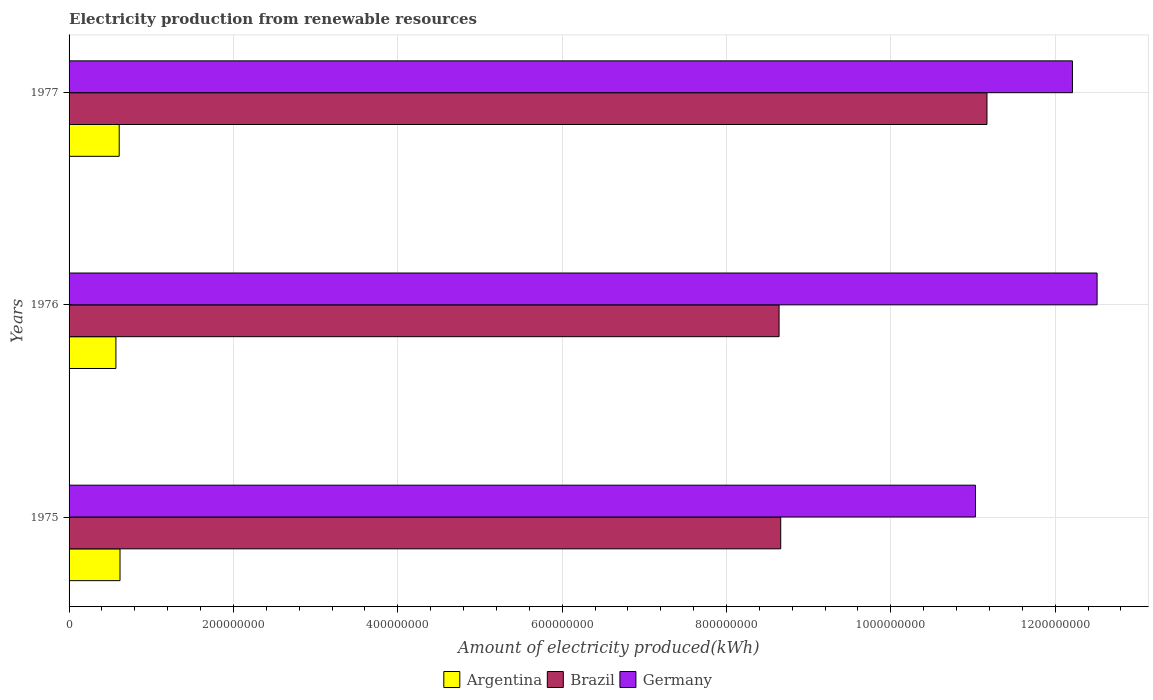How many different coloured bars are there?
Your answer should be compact. 3. Are the number of bars per tick equal to the number of legend labels?
Your response must be concise. Yes. How many bars are there on the 1st tick from the top?
Your response must be concise. 3. What is the label of the 2nd group of bars from the top?
Make the answer very short. 1976. In how many cases, is the number of bars for a given year not equal to the number of legend labels?
Give a very brief answer. 0. What is the amount of electricity produced in Argentina in 1975?
Ensure brevity in your answer.  6.20e+07. Across all years, what is the maximum amount of electricity produced in Brazil?
Offer a terse response. 1.12e+09. Across all years, what is the minimum amount of electricity produced in Brazil?
Provide a short and direct response. 8.64e+08. In which year was the amount of electricity produced in Argentina maximum?
Offer a very short reply. 1975. In which year was the amount of electricity produced in Argentina minimum?
Make the answer very short. 1976. What is the total amount of electricity produced in Brazil in the graph?
Your response must be concise. 2.85e+09. What is the difference between the amount of electricity produced in Germany in 1976 and that in 1977?
Your answer should be very brief. 3.00e+07. What is the difference between the amount of electricity produced in Brazil in 1975 and the amount of electricity produced in Argentina in 1976?
Provide a short and direct response. 8.09e+08. What is the average amount of electricity produced in Germany per year?
Make the answer very short. 1.19e+09. In the year 1977, what is the difference between the amount of electricity produced in Germany and amount of electricity produced in Argentina?
Your answer should be compact. 1.16e+09. What is the ratio of the amount of electricity produced in Argentina in 1975 to that in 1976?
Your response must be concise. 1.09. What is the difference between the highest and the second highest amount of electricity produced in Brazil?
Provide a short and direct response. 2.51e+08. In how many years, is the amount of electricity produced in Brazil greater than the average amount of electricity produced in Brazil taken over all years?
Your answer should be very brief. 1. Is the sum of the amount of electricity produced in Brazil in 1975 and 1976 greater than the maximum amount of electricity produced in Argentina across all years?
Your answer should be compact. Yes. Is it the case that in every year, the sum of the amount of electricity produced in Argentina and amount of electricity produced in Brazil is greater than the amount of electricity produced in Germany?
Your response must be concise. No. How many bars are there?
Provide a succinct answer. 9. What is the difference between two consecutive major ticks on the X-axis?
Offer a terse response. 2.00e+08. Does the graph contain any zero values?
Offer a terse response. No. Does the graph contain grids?
Provide a short and direct response. Yes. How are the legend labels stacked?
Your answer should be very brief. Horizontal. What is the title of the graph?
Your answer should be very brief. Electricity production from renewable resources. Does "Timor-Leste" appear as one of the legend labels in the graph?
Keep it short and to the point. No. What is the label or title of the X-axis?
Keep it short and to the point. Amount of electricity produced(kWh). What is the label or title of the Y-axis?
Your answer should be compact. Years. What is the Amount of electricity produced(kWh) in Argentina in 1975?
Offer a very short reply. 6.20e+07. What is the Amount of electricity produced(kWh) of Brazil in 1975?
Offer a very short reply. 8.66e+08. What is the Amount of electricity produced(kWh) of Germany in 1975?
Your response must be concise. 1.10e+09. What is the Amount of electricity produced(kWh) of Argentina in 1976?
Make the answer very short. 5.70e+07. What is the Amount of electricity produced(kWh) in Brazil in 1976?
Ensure brevity in your answer.  8.64e+08. What is the Amount of electricity produced(kWh) in Germany in 1976?
Give a very brief answer. 1.25e+09. What is the Amount of electricity produced(kWh) in Argentina in 1977?
Provide a succinct answer. 6.10e+07. What is the Amount of electricity produced(kWh) in Brazil in 1977?
Keep it short and to the point. 1.12e+09. What is the Amount of electricity produced(kWh) of Germany in 1977?
Offer a very short reply. 1.22e+09. Across all years, what is the maximum Amount of electricity produced(kWh) in Argentina?
Your response must be concise. 6.20e+07. Across all years, what is the maximum Amount of electricity produced(kWh) in Brazil?
Make the answer very short. 1.12e+09. Across all years, what is the maximum Amount of electricity produced(kWh) of Germany?
Ensure brevity in your answer.  1.25e+09. Across all years, what is the minimum Amount of electricity produced(kWh) in Argentina?
Offer a very short reply. 5.70e+07. Across all years, what is the minimum Amount of electricity produced(kWh) in Brazil?
Ensure brevity in your answer.  8.64e+08. Across all years, what is the minimum Amount of electricity produced(kWh) in Germany?
Make the answer very short. 1.10e+09. What is the total Amount of electricity produced(kWh) in Argentina in the graph?
Your answer should be very brief. 1.80e+08. What is the total Amount of electricity produced(kWh) in Brazil in the graph?
Your answer should be compact. 2.85e+09. What is the total Amount of electricity produced(kWh) of Germany in the graph?
Offer a terse response. 3.58e+09. What is the difference between the Amount of electricity produced(kWh) of Argentina in 1975 and that in 1976?
Provide a succinct answer. 5.00e+06. What is the difference between the Amount of electricity produced(kWh) of Brazil in 1975 and that in 1976?
Keep it short and to the point. 2.00e+06. What is the difference between the Amount of electricity produced(kWh) in Germany in 1975 and that in 1976?
Your response must be concise. -1.48e+08. What is the difference between the Amount of electricity produced(kWh) in Brazil in 1975 and that in 1977?
Keep it short and to the point. -2.51e+08. What is the difference between the Amount of electricity produced(kWh) in Germany in 1975 and that in 1977?
Ensure brevity in your answer.  -1.18e+08. What is the difference between the Amount of electricity produced(kWh) of Argentina in 1976 and that in 1977?
Keep it short and to the point. -4.00e+06. What is the difference between the Amount of electricity produced(kWh) of Brazil in 1976 and that in 1977?
Give a very brief answer. -2.53e+08. What is the difference between the Amount of electricity produced(kWh) in Germany in 1976 and that in 1977?
Provide a short and direct response. 3.00e+07. What is the difference between the Amount of electricity produced(kWh) in Argentina in 1975 and the Amount of electricity produced(kWh) in Brazil in 1976?
Your answer should be very brief. -8.02e+08. What is the difference between the Amount of electricity produced(kWh) of Argentina in 1975 and the Amount of electricity produced(kWh) of Germany in 1976?
Your answer should be very brief. -1.19e+09. What is the difference between the Amount of electricity produced(kWh) in Brazil in 1975 and the Amount of electricity produced(kWh) in Germany in 1976?
Give a very brief answer. -3.85e+08. What is the difference between the Amount of electricity produced(kWh) of Argentina in 1975 and the Amount of electricity produced(kWh) of Brazil in 1977?
Offer a very short reply. -1.06e+09. What is the difference between the Amount of electricity produced(kWh) of Argentina in 1975 and the Amount of electricity produced(kWh) of Germany in 1977?
Keep it short and to the point. -1.16e+09. What is the difference between the Amount of electricity produced(kWh) in Brazil in 1975 and the Amount of electricity produced(kWh) in Germany in 1977?
Offer a terse response. -3.55e+08. What is the difference between the Amount of electricity produced(kWh) of Argentina in 1976 and the Amount of electricity produced(kWh) of Brazil in 1977?
Your answer should be compact. -1.06e+09. What is the difference between the Amount of electricity produced(kWh) of Argentina in 1976 and the Amount of electricity produced(kWh) of Germany in 1977?
Ensure brevity in your answer.  -1.16e+09. What is the difference between the Amount of electricity produced(kWh) of Brazil in 1976 and the Amount of electricity produced(kWh) of Germany in 1977?
Ensure brevity in your answer.  -3.57e+08. What is the average Amount of electricity produced(kWh) of Argentina per year?
Offer a terse response. 6.00e+07. What is the average Amount of electricity produced(kWh) of Brazil per year?
Ensure brevity in your answer.  9.49e+08. What is the average Amount of electricity produced(kWh) of Germany per year?
Ensure brevity in your answer.  1.19e+09. In the year 1975, what is the difference between the Amount of electricity produced(kWh) in Argentina and Amount of electricity produced(kWh) in Brazil?
Offer a very short reply. -8.04e+08. In the year 1975, what is the difference between the Amount of electricity produced(kWh) of Argentina and Amount of electricity produced(kWh) of Germany?
Your response must be concise. -1.04e+09. In the year 1975, what is the difference between the Amount of electricity produced(kWh) in Brazil and Amount of electricity produced(kWh) in Germany?
Your answer should be compact. -2.37e+08. In the year 1976, what is the difference between the Amount of electricity produced(kWh) in Argentina and Amount of electricity produced(kWh) in Brazil?
Your response must be concise. -8.07e+08. In the year 1976, what is the difference between the Amount of electricity produced(kWh) of Argentina and Amount of electricity produced(kWh) of Germany?
Your answer should be compact. -1.19e+09. In the year 1976, what is the difference between the Amount of electricity produced(kWh) in Brazil and Amount of electricity produced(kWh) in Germany?
Keep it short and to the point. -3.87e+08. In the year 1977, what is the difference between the Amount of electricity produced(kWh) of Argentina and Amount of electricity produced(kWh) of Brazil?
Offer a very short reply. -1.06e+09. In the year 1977, what is the difference between the Amount of electricity produced(kWh) of Argentina and Amount of electricity produced(kWh) of Germany?
Ensure brevity in your answer.  -1.16e+09. In the year 1977, what is the difference between the Amount of electricity produced(kWh) in Brazil and Amount of electricity produced(kWh) in Germany?
Your response must be concise. -1.04e+08. What is the ratio of the Amount of electricity produced(kWh) of Argentina in 1975 to that in 1976?
Your answer should be compact. 1.09. What is the ratio of the Amount of electricity produced(kWh) of Germany in 1975 to that in 1976?
Your answer should be compact. 0.88. What is the ratio of the Amount of electricity produced(kWh) in Argentina in 1975 to that in 1977?
Give a very brief answer. 1.02. What is the ratio of the Amount of electricity produced(kWh) in Brazil in 1975 to that in 1977?
Make the answer very short. 0.78. What is the ratio of the Amount of electricity produced(kWh) of Germany in 1975 to that in 1977?
Offer a very short reply. 0.9. What is the ratio of the Amount of electricity produced(kWh) of Argentina in 1976 to that in 1977?
Offer a terse response. 0.93. What is the ratio of the Amount of electricity produced(kWh) in Brazil in 1976 to that in 1977?
Ensure brevity in your answer.  0.77. What is the ratio of the Amount of electricity produced(kWh) of Germany in 1976 to that in 1977?
Your answer should be compact. 1.02. What is the difference between the highest and the second highest Amount of electricity produced(kWh) in Brazil?
Make the answer very short. 2.51e+08. What is the difference between the highest and the second highest Amount of electricity produced(kWh) of Germany?
Provide a short and direct response. 3.00e+07. What is the difference between the highest and the lowest Amount of electricity produced(kWh) of Brazil?
Make the answer very short. 2.53e+08. What is the difference between the highest and the lowest Amount of electricity produced(kWh) of Germany?
Offer a terse response. 1.48e+08. 